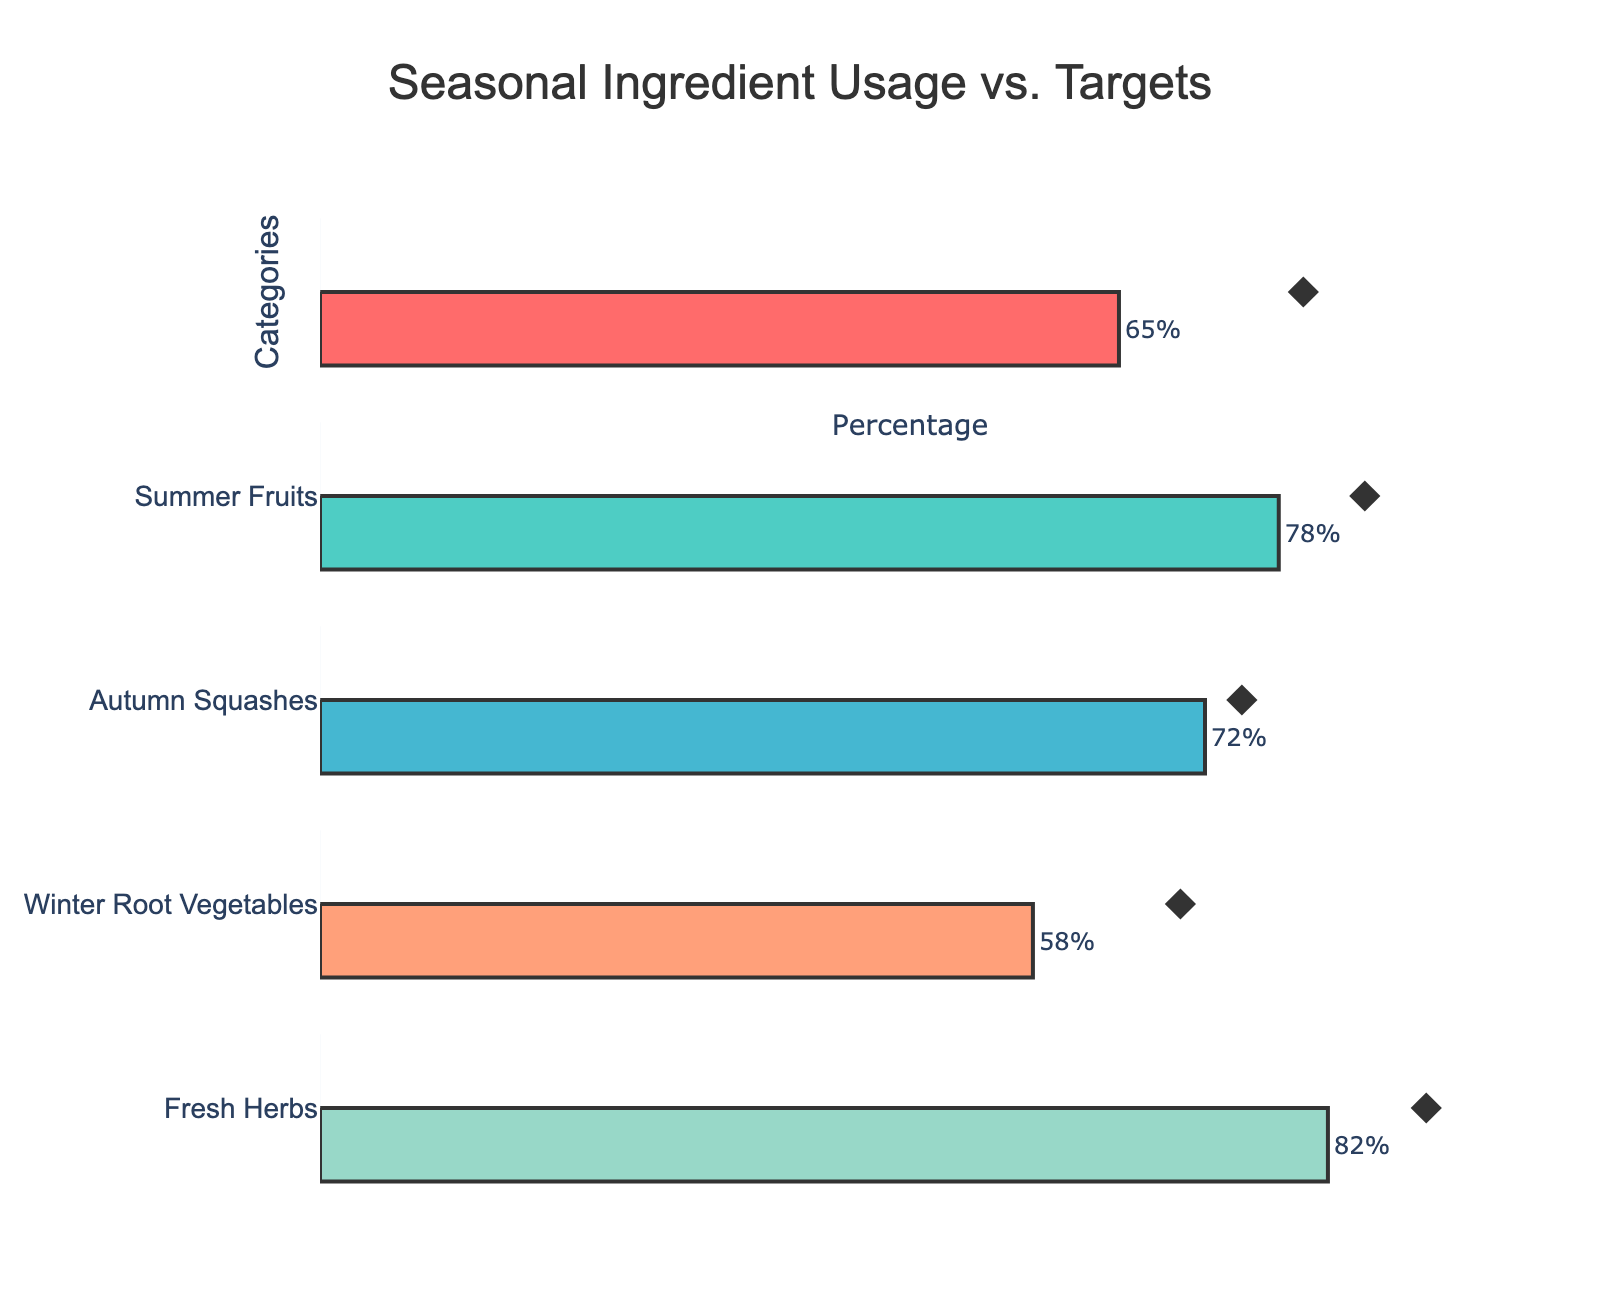What's the title of the chart? The title is typically found at the top of the chart as a large text. Here, the plot title is 'Seasonal Ingredient Usage vs. Targets,' which indicates the relationship between the actual usage of seasonal ingredients in recipes and their target goals.
Answer: Seasonal Ingredient Usage vs. Targets Which category has the highest percentage of recipes using seasonal ingredients? By looking at the bars representing the actual percentages, we can see which one extends the furthest to the right. The 'Fresh Herbs' category has the highest percentage at 82%.
Answer: Fresh Herbs What is the target percentage for 'Summer Fruits'? A target value is usually depicted using markers like diamonds in this chart. The diamond marker for 'Summer Fruits' is located at 85%, indicating the target percentage.
Answer: 85% Does any category meet its 'Good' range? The 'Good' range is denoted by the light blue segment in the background bars. Only 'Fresh Herbs,' with an actual usage of 82%, falls within the 'Good' range starting from 80%.
Answer: Yes, Fresh Herbs Which category is furthest from meeting its target goal, and by how much? To determine this, calculate the absolute difference between the actual percentage and the target percentage for each category. The largest absolute difference is between the 'Winter Root Vegetables' actual percentage of 58% and its target of 70%, which is a difference of 12%.
Answer: Winter Root Vegetables, 12% What is the average actual percentage across all categories? Add up the actual percentages for all categories and divide by the number of categories: (65 + 78 + 72 + 58 + 82)/5 = 71.
Answer: 71% Which category has the smallest gap between the 'Actual' and 'Target' percentages? Calculate the differences for each category. 'Autumn Squashes' has a target of 75% and an actual of 72%, resulting in the smallest gap of 3%.
Answer: Autumn Squashes How many categories fall within their 'Satisfactory' ranges? Satisfactory range is marked in green. By visually checking which categories' bars fall in the green range: 'Spring Vegetables,' 'Summer Fruits,' 'Autumn Squashes,' and 'Winter Root Vegetables' fall within their satisfactory ranges, so 4 categories.
Answer: 4 Which category has an actual percentage below its 'Satisfactory' range and by how much? Checking whether the 'Actual' percentage falls below the green segment ('Satisfactory' range) and the amount by which it is lower, 'Winter Root Vegetables' at 58% falls below its 'Satisfactory' range starting at 60% by 2%.
Answer: Winter Root Vegetables, 2% Is there any category where the actual usage percentage is equal to the target percentage? By comparing actual percentages with target percentages, no categories show a case where the 'Actual' value exactly matches the 'Target'.
Answer: No 